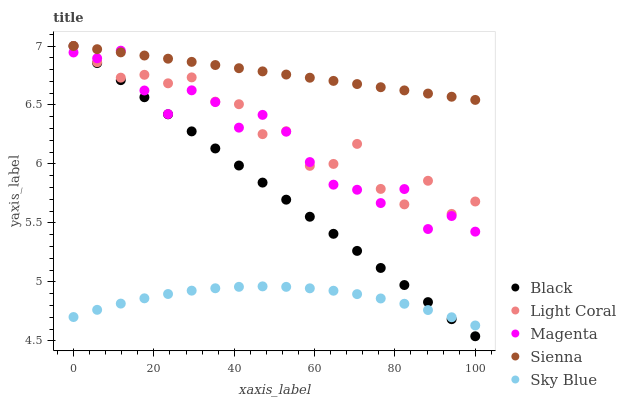Does Sky Blue have the minimum area under the curve?
Answer yes or no. Yes. Does Sienna have the maximum area under the curve?
Answer yes or no. Yes. Does Magenta have the minimum area under the curve?
Answer yes or no. No. Does Magenta have the maximum area under the curve?
Answer yes or no. No. Is Sienna the smoothest?
Answer yes or no. Yes. Is Light Coral the roughest?
Answer yes or no. Yes. Is Magenta the smoothest?
Answer yes or no. No. Is Magenta the roughest?
Answer yes or no. No. Does Black have the lowest value?
Answer yes or no. Yes. Does Magenta have the lowest value?
Answer yes or no. No. Does Black have the highest value?
Answer yes or no. Yes. Does Magenta have the highest value?
Answer yes or no. No. Is Sky Blue less than Light Coral?
Answer yes or no. Yes. Is Magenta greater than Sky Blue?
Answer yes or no. Yes. Does Black intersect Sienna?
Answer yes or no. Yes. Is Black less than Sienna?
Answer yes or no. No. Is Black greater than Sienna?
Answer yes or no. No. Does Sky Blue intersect Light Coral?
Answer yes or no. No. 